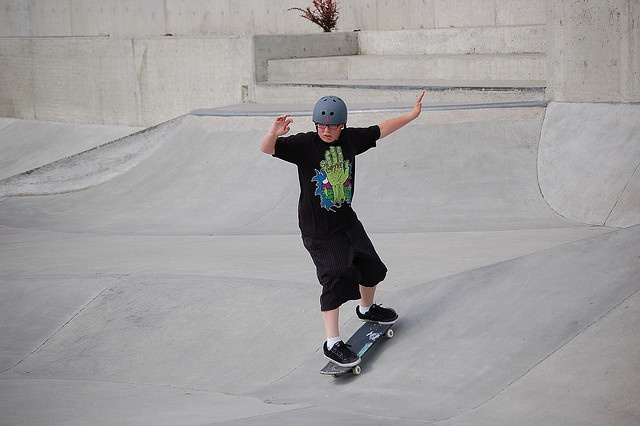Describe the objects in this image and their specific colors. I can see people in gray, black, brown, and darkgray tones and skateboard in gray, darkblue, and black tones in this image. 